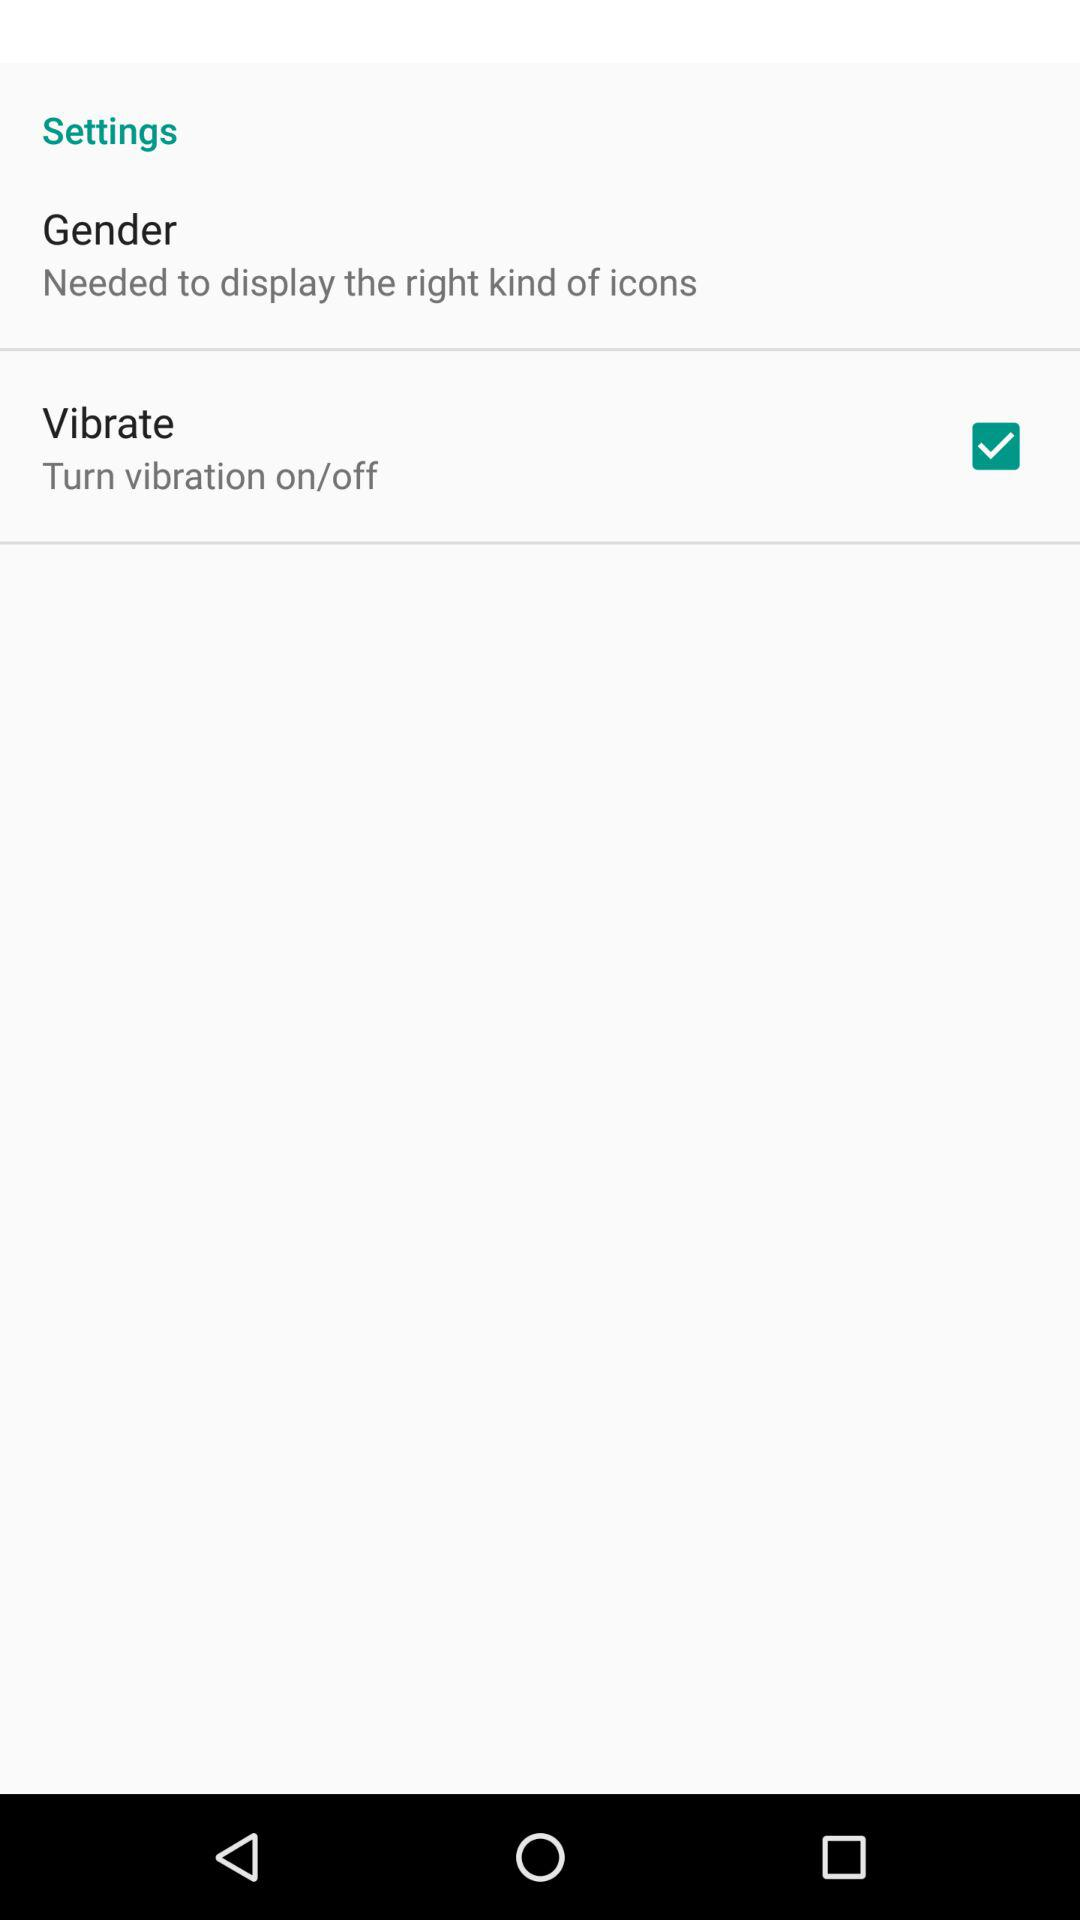Which option is check marked? The check marked option is "Vibrate". 